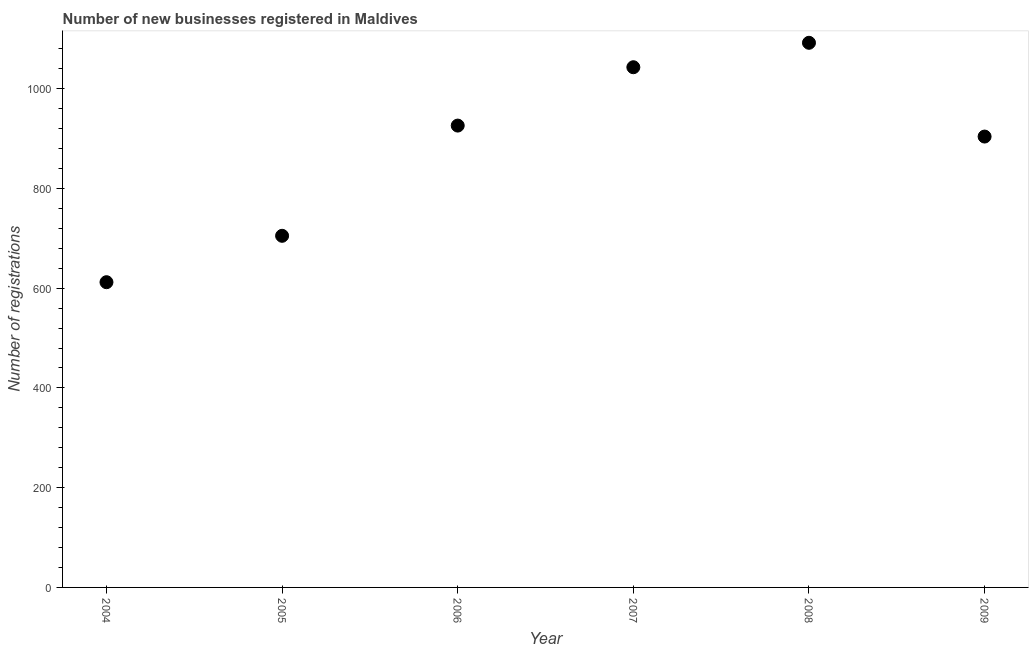What is the number of new business registrations in 2006?
Your response must be concise. 926. Across all years, what is the maximum number of new business registrations?
Keep it short and to the point. 1092. Across all years, what is the minimum number of new business registrations?
Keep it short and to the point. 612. What is the sum of the number of new business registrations?
Provide a succinct answer. 5282. What is the difference between the number of new business registrations in 2004 and 2007?
Offer a very short reply. -431. What is the average number of new business registrations per year?
Give a very brief answer. 880.33. What is the median number of new business registrations?
Keep it short and to the point. 915. What is the ratio of the number of new business registrations in 2004 to that in 2007?
Give a very brief answer. 0.59. Is the difference between the number of new business registrations in 2004 and 2009 greater than the difference between any two years?
Give a very brief answer. No. What is the difference between the highest and the lowest number of new business registrations?
Your answer should be very brief. 480. Does the number of new business registrations monotonically increase over the years?
Give a very brief answer. No. How many years are there in the graph?
Make the answer very short. 6. What is the difference between two consecutive major ticks on the Y-axis?
Your response must be concise. 200. Does the graph contain any zero values?
Provide a short and direct response. No. Does the graph contain grids?
Provide a succinct answer. No. What is the title of the graph?
Provide a succinct answer. Number of new businesses registered in Maldives. What is the label or title of the X-axis?
Your answer should be very brief. Year. What is the label or title of the Y-axis?
Provide a short and direct response. Number of registrations. What is the Number of registrations in 2004?
Offer a terse response. 612. What is the Number of registrations in 2005?
Provide a short and direct response. 705. What is the Number of registrations in 2006?
Your response must be concise. 926. What is the Number of registrations in 2007?
Give a very brief answer. 1043. What is the Number of registrations in 2008?
Ensure brevity in your answer.  1092. What is the Number of registrations in 2009?
Your answer should be compact. 904. What is the difference between the Number of registrations in 2004 and 2005?
Provide a short and direct response. -93. What is the difference between the Number of registrations in 2004 and 2006?
Offer a very short reply. -314. What is the difference between the Number of registrations in 2004 and 2007?
Your response must be concise. -431. What is the difference between the Number of registrations in 2004 and 2008?
Provide a short and direct response. -480. What is the difference between the Number of registrations in 2004 and 2009?
Provide a succinct answer. -292. What is the difference between the Number of registrations in 2005 and 2006?
Provide a short and direct response. -221. What is the difference between the Number of registrations in 2005 and 2007?
Your answer should be very brief. -338. What is the difference between the Number of registrations in 2005 and 2008?
Make the answer very short. -387. What is the difference between the Number of registrations in 2005 and 2009?
Make the answer very short. -199. What is the difference between the Number of registrations in 2006 and 2007?
Your answer should be very brief. -117. What is the difference between the Number of registrations in 2006 and 2008?
Your answer should be compact. -166. What is the difference between the Number of registrations in 2007 and 2008?
Keep it short and to the point. -49. What is the difference between the Number of registrations in 2007 and 2009?
Provide a short and direct response. 139. What is the difference between the Number of registrations in 2008 and 2009?
Keep it short and to the point. 188. What is the ratio of the Number of registrations in 2004 to that in 2005?
Keep it short and to the point. 0.87. What is the ratio of the Number of registrations in 2004 to that in 2006?
Keep it short and to the point. 0.66. What is the ratio of the Number of registrations in 2004 to that in 2007?
Ensure brevity in your answer.  0.59. What is the ratio of the Number of registrations in 2004 to that in 2008?
Ensure brevity in your answer.  0.56. What is the ratio of the Number of registrations in 2004 to that in 2009?
Make the answer very short. 0.68. What is the ratio of the Number of registrations in 2005 to that in 2006?
Your answer should be very brief. 0.76. What is the ratio of the Number of registrations in 2005 to that in 2007?
Give a very brief answer. 0.68. What is the ratio of the Number of registrations in 2005 to that in 2008?
Provide a short and direct response. 0.65. What is the ratio of the Number of registrations in 2005 to that in 2009?
Your answer should be very brief. 0.78. What is the ratio of the Number of registrations in 2006 to that in 2007?
Offer a terse response. 0.89. What is the ratio of the Number of registrations in 2006 to that in 2008?
Provide a short and direct response. 0.85. What is the ratio of the Number of registrations in 2006 to that in 2009?
Offer a terse response. 1.02. What is the ratio of the Number of registrations in 2007 to that in 2008?
Your answer should be compact. 0.95. What is the ratio of the Number of registrations in 2007 to that in 2009?
Make the answer very short. 1.15. What is the ratio of the Number of registrations in 2008 to that in 2009?
Offer a very short reply. 1.21. 